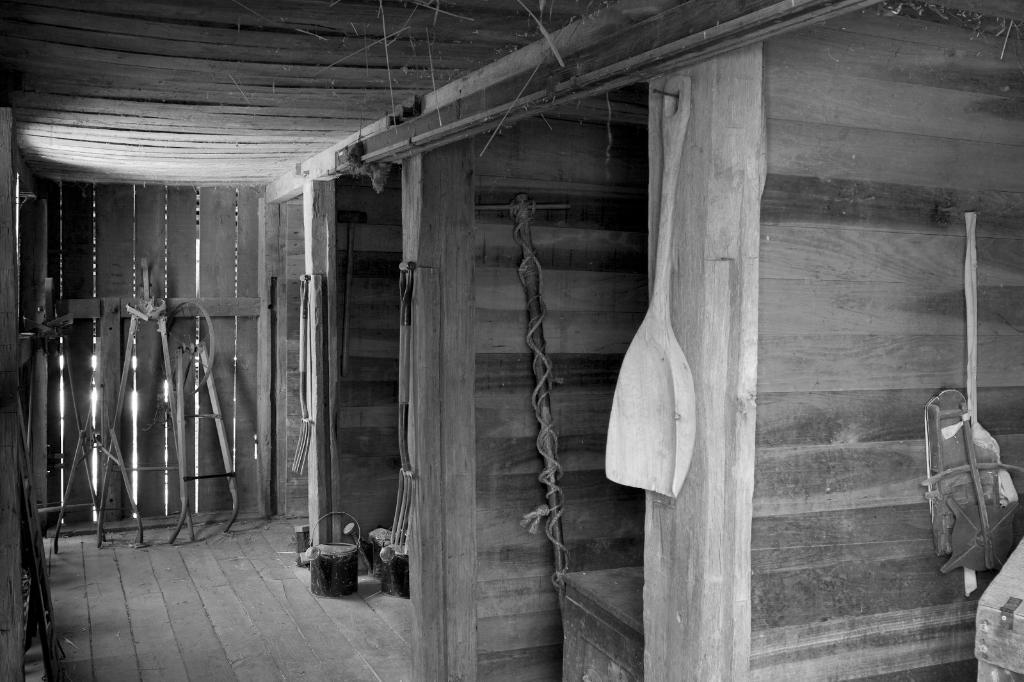What utensil is visible in the image? There is a spoon in the image. What type of structural elements can be seen in the image? There are rods and wooden planks visible in the image. What other objects are present in the image? There are other objects in the image, but their specific details are not mentioned in the provided facts. What can be seen in the background of the image? There is a wall and a roof in the background of the image. What type of bun is being used to hold the books in the library in the image? There is no library or bun present in the image. What color is the orange in the image? There is no orange present in the image. 